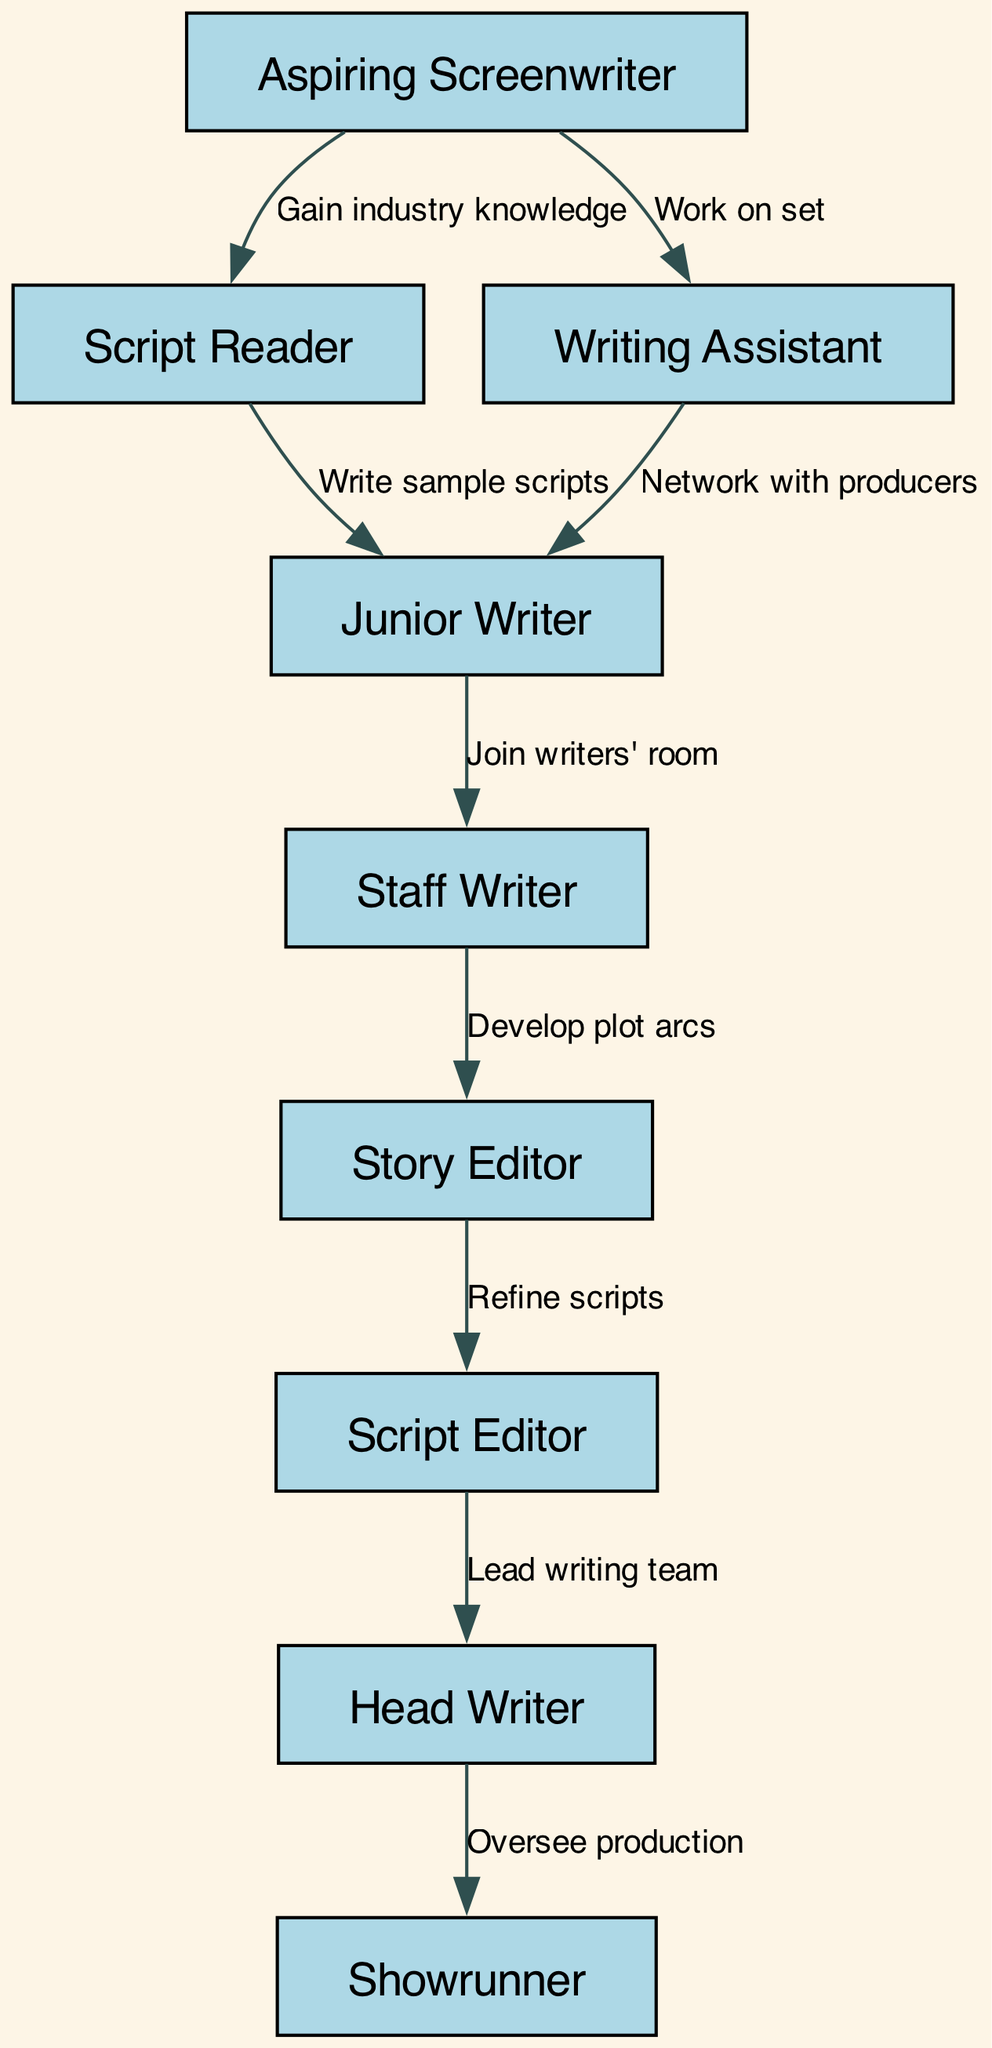What is the first step for an Aspiring Screenwriter? The directed graph indicates that an Aspiring Screenwriter can either gain industry knowledge by becoming a Script Reader or work on set as a Writing Assistant. Both of these options are directly linked to the Aspiring Screenwriter node. Therefore, the first step could be one of those two paths.
Answer: Gain industry knowledge or Work on set How many nodes are in this diagram? The diagram has a list of distinct roles connected by paths. Counting each unique role, we find there are nine nodes in total.
Answer: 9 What role comes after a Junior Writer? Following the directed flow from the Junior Writer node, the next role indicated is Staff Writer. This is shown by the arrow pointing from Junior Writer to Staff Writer.
Answer: Staff Writer Which two roles are connected directly to the Aspiring Screenwriter? The two roles directly connected to the Aspiring Screenwriter are Script Reader and Writing Assistant. These connections represent the options available to an Aspiring Screenwriter.
Answer: Script Reader and Writing Assistant What is the final role in the career progression path? By examining the edges leading away from the nodes, the diagram shows that the last role in the path is Showrunner. This role is reached last after progressing through Head Writer.
Answer: Showrunner What action leads from Staff Writer to Story Editor? The edge from Staff Writer to Story Editor is labelled "Develop plot arcs," indicating the specific action that transitions a Staff Writer to a Story Editor. This is vital in understanding the responsibilities that encompass this step.
Answer: Develop plot arcs Which role involves overseeing production? After tracing the connections, the role that entails overseeing production is Showrunner. This indicates its leadership position in the final stages of the career path.
Answer: Showrunner How many edges are there in total? Looking through the graph, each connection or pathway between nodes counts as an edge. There are eight edges depicted in the diagram, showcasing the transitions between various roles.
Answer: 8 